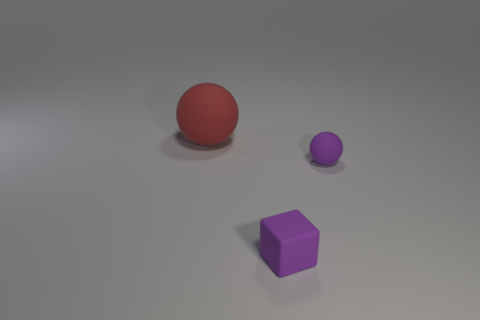Are there an equal number of spheres to the left of the red object and small purple objects that are left of the purple block?
Offer a very short reply. Yes. There is a rubber object that is right of the tiny cube; what is its shape?
Give a very brief answer. Sphere. What shape is the thing that is the same size as the purple ball?
Your answer should be very brief. Cube. There is a rubber object in front of the tiny object behind the rubber object that is in front of the tiny sphere; what is its color?
Ensure brevity in your answer.  Purple. Are there the same number of spheres that are to the right of the red sphere and small purple rubber objects?
Keep it short and to the point. No. How many other objects are the same material as the red ball?
Provide a succinct answer. 2. There is a purple matte thing to the left of the purple ball; does it have the same size as the sphere in front of the big thing?
Provide a short and direct response. Yes. How many things are rubber spheres right of the big rubber ball or tiny rubber things that are on the right side of the small purple block?
Make the answer very short. 1. Are there any other things that are the same shape as the red thing?
Your answer should be compact. Yes. Does the tiny thing that is in front of the purple sphere have the same color as the sphere in front of the red object?
Your response must be concise. Yes. 